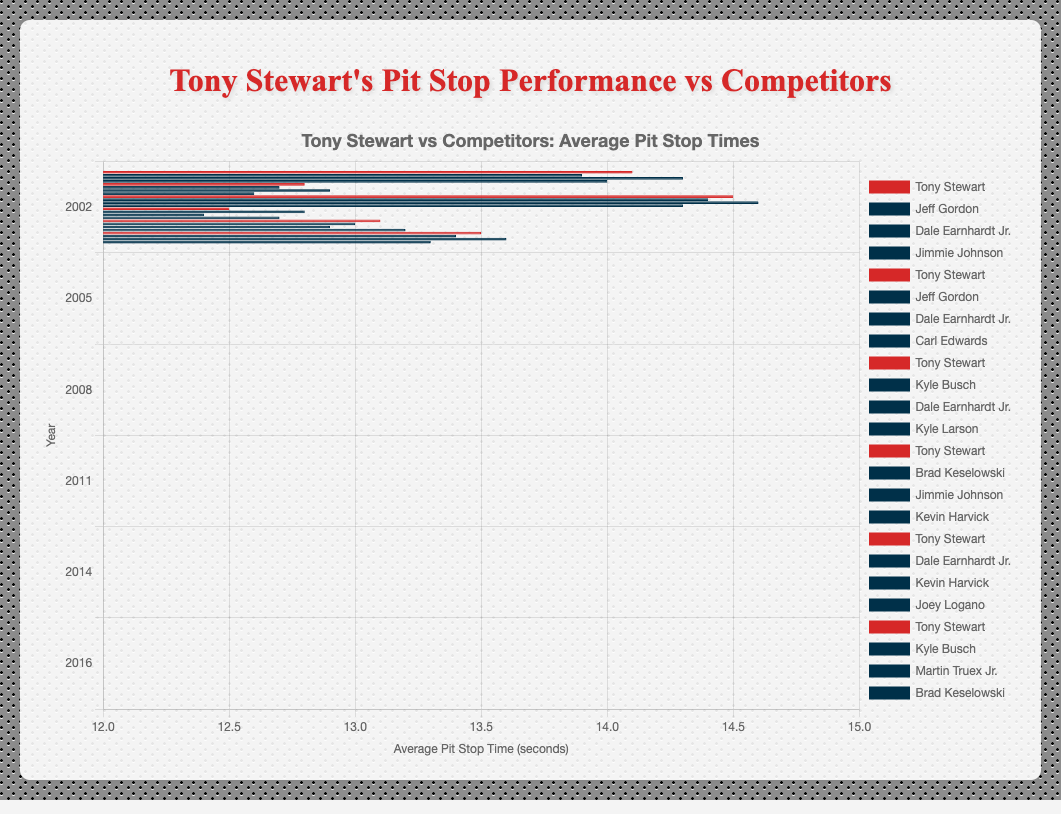Which year had the fastest average pit stop time for Tony Stewart? Check the chart for the shortest bar representing Tony Stewart.
Answer: 2011 Who had the fastest average pit stop time in 2008? Look for the shortest bar in the 2008 group. It's Kyle Larson with 14.3 seconds.
Answer: Kyle Larson In 2005, how much slower was Tony Stewart compared to Carl Edwards? Subtract Tony Stewart's average pit stop time (12.8) from Carl Edwards' (12.6).
Answer: 0.2 seconds Calculate the average pit stop time for all competitors in 2011. Add up all competitors' times (12.8 + 12.4 + 12.7) and divide by 3.
Answer: 12.63 seconds Compare Tony Stewart's 2014 average pit stop time with Dale Earnhardt Jr.'s. Who was faster and by how much? Dale Earnhardt Jr. had 13.0 seconds compared to Tony Stewart's 13.1 seconds. Subtract Dale's time from Tony's.
Answer: Dale Earnhardt Jr., by 0.1 seconds In which years did Tony Stewart's team have a slower average pit stop time than at least one competitor? Compare Tony Stewart's times each year with the competitors. The years are 2002, 2005, 2008, 2014, 2016.
Answer: 2002, 2005, 2008, 2014, 2016 Between 2002 and 2016, which year did Tony Stewart's team show the greatest improvement in pit stop time compared to its previous performance? Calculate the difference between consecutive years' times and find the greatest positive change: (14.1-12.8=1.3), (12.8-14.5=-1.7), (14.5-12.5=2.0), (12.5-13.1=-0.6), (13.1-13.5=-0.4).
Answer: 2011 How does Tony Stewart's average pit stop time in 2016 compare to Kevin Harvick's in 2014? Both have their respective average pit stop times in the chart. Compare Tony Stewart's 2016 time (13.5) to Kevin Harvick's 2014 time (12.9).
Answer: Tony Stewart was 0.6 seconds slower What is the range of Tony Stewart's average pit stop times over the years? Find the difference between the maximum and minimum values of Tony Stewart's times (14.5 - 12.5).
Answer: 2.0 seconds In 2005, who had the slowest average pit stop time, and how much slower were they compared to the fastest competitor? The slowest was Dale Earnhardt Jr. with 12.9 seconds, and the fastest competitor was Carl Edwards with 12.6 seconds. Subtract these times.
Answer: Dale Earnhardt Jr. by 0.3 seconds 